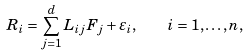Convert formula to latex. <formula><loc_0><loc_0><loc_500><loc_500>R _ { i } = \sum _ { j = 1 } ^ { d } L _ { i j } F _ { j } + \varepsilon _ { i } , \quad i = 1 , \dots , n ,</formula> 